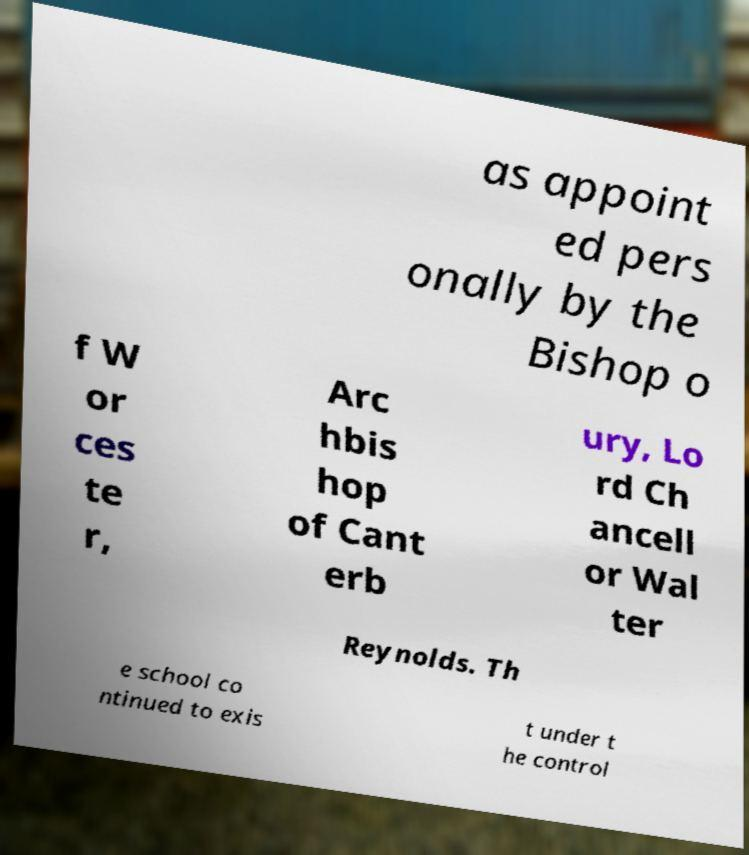Can you read and provide the text displayed in the image?This photo seems to have some interesting text. Can you extract and type it out for me? as appoint ed pers onally by the Bishop o f W or ces te r, Arc hbis hop of Cant erb ury, Lo rd Ch ancell or Wal ter Reynolds. Th e school co ntinued to exis t under t he control 